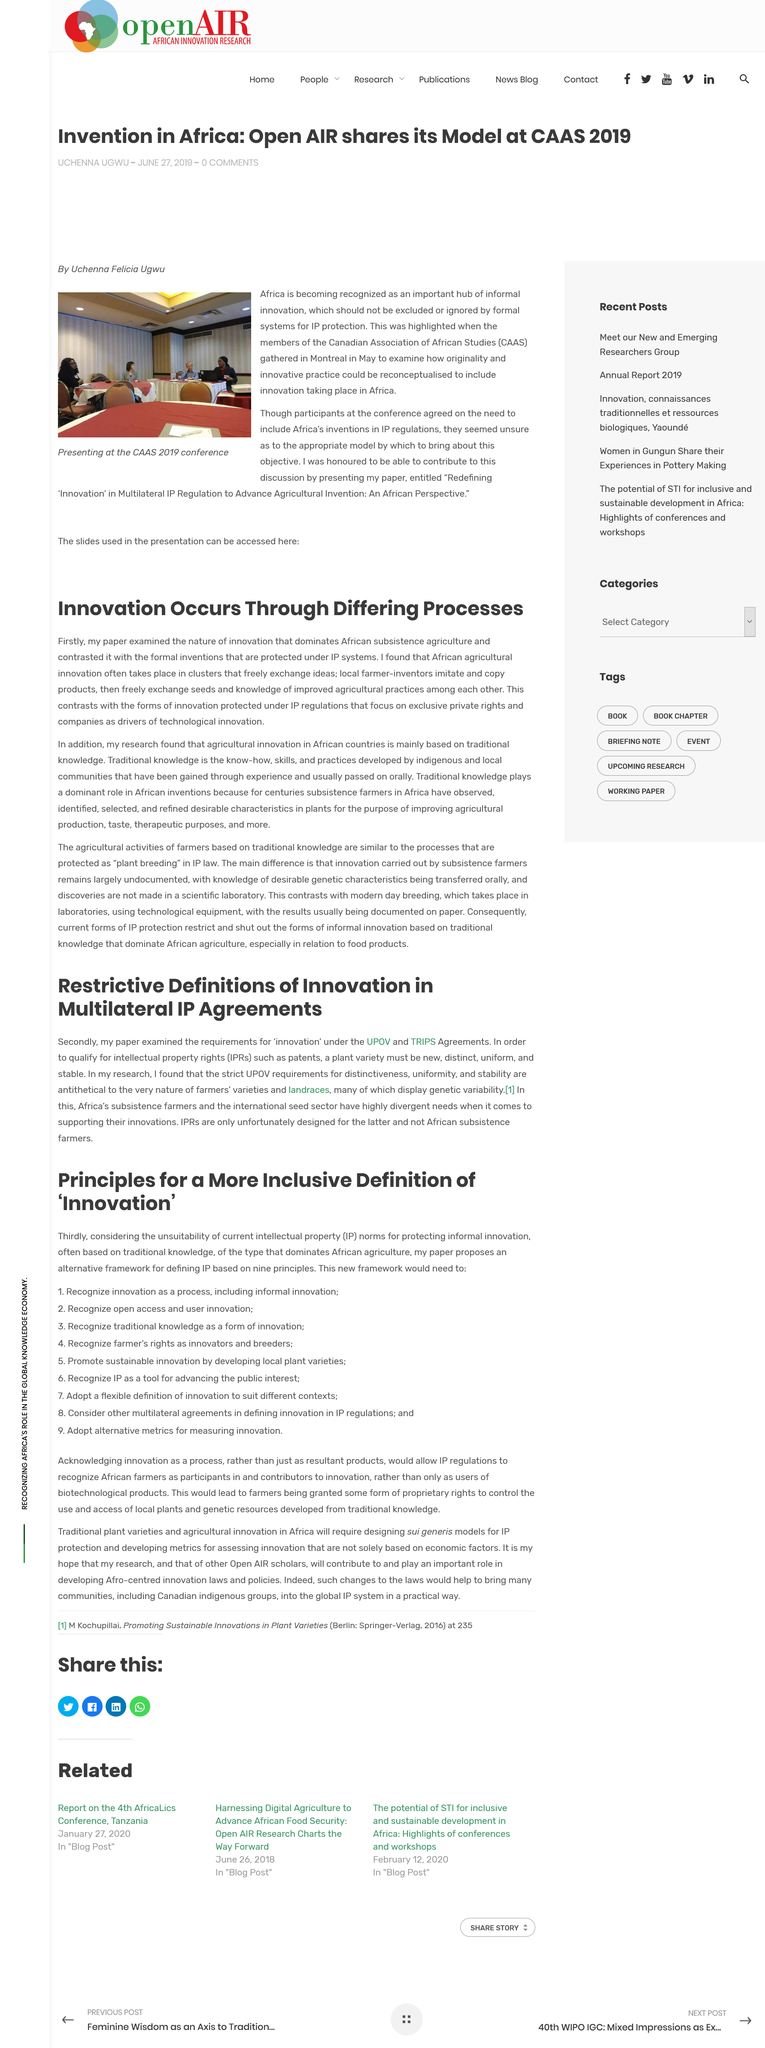Specify some key components in this picture. The examination of agreements such as UPOV and TRIPS that defined the requirements for "innovation" was reviewed. IPRS is designed for individuals and organizations in the field of plant sciences and related fields, and is not intended for African subsistence farmers. The paper examined the nature of innovation that dominates subsistence agriculture in Africa. It has been found that African agricultural innovation often takes place in clusters where free exchange of ideas is encouraged. Intellectual property rights, specifically patents, trademarks, and copyrights, are crucial to the success of a business. 